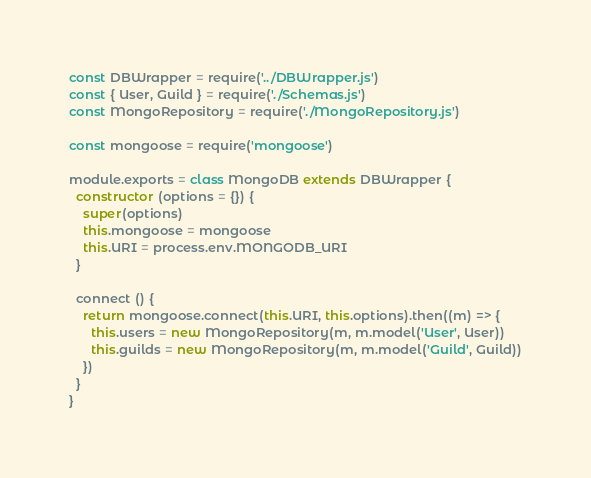Convert code to text. <code><loc_0><loc_0><loc_500><loc_500><_JavaScript_>const DBWrapper = require('../DBWrapper.js')
const { User, Guild } = require('./Schemas.js')
const MongoRepository = require('./MongoRepository.js')

const mongoose = require('mongoose')

module.exports = class MongoDB extends DBWrapper {
  constructor (options = {}) {
    super(options)
    this.mongoose = mongoose
    this.URI = process.env.MONGODB_URI
  }

  connect () {
    return mongoose.connect(this.URI, this.options).then((m) => {
      this.users = new MongoRepository(m, m.model('User', User))
      this.guilds = new MongoRepository(m, m.model('Guild', Guild))
    })
  }
}
</code> 